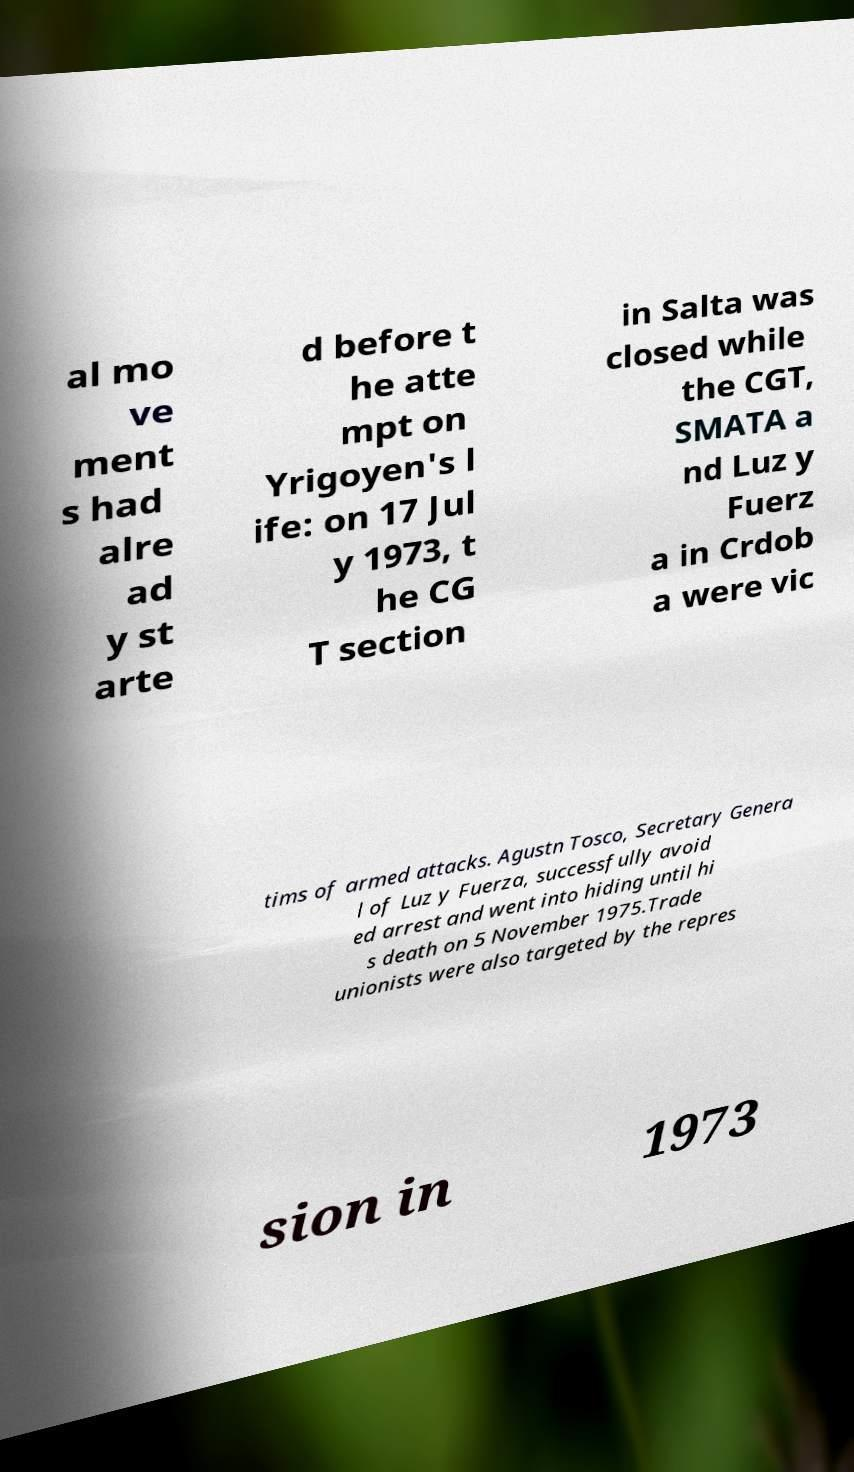What messages or text are displayed in this image? I need them in a readable, typed format. al mo ve ment s had alre ad y st arte d before t he atte mpt on Yrigoyen's l ife: on 17 Jul y 1973, t he CG T section in Salta was closed while the CGT, SMATA a nd Luz y Fuerz a in Crdob a were vic tims of armed attacks. Agustn Tosco, Secretary Genera l of Luz y Fuerza, successfully avoid ed arrest and went into hiding until hi s death on 5 November 1975.Trade unionists were also targeted by the repres sion in 1973 